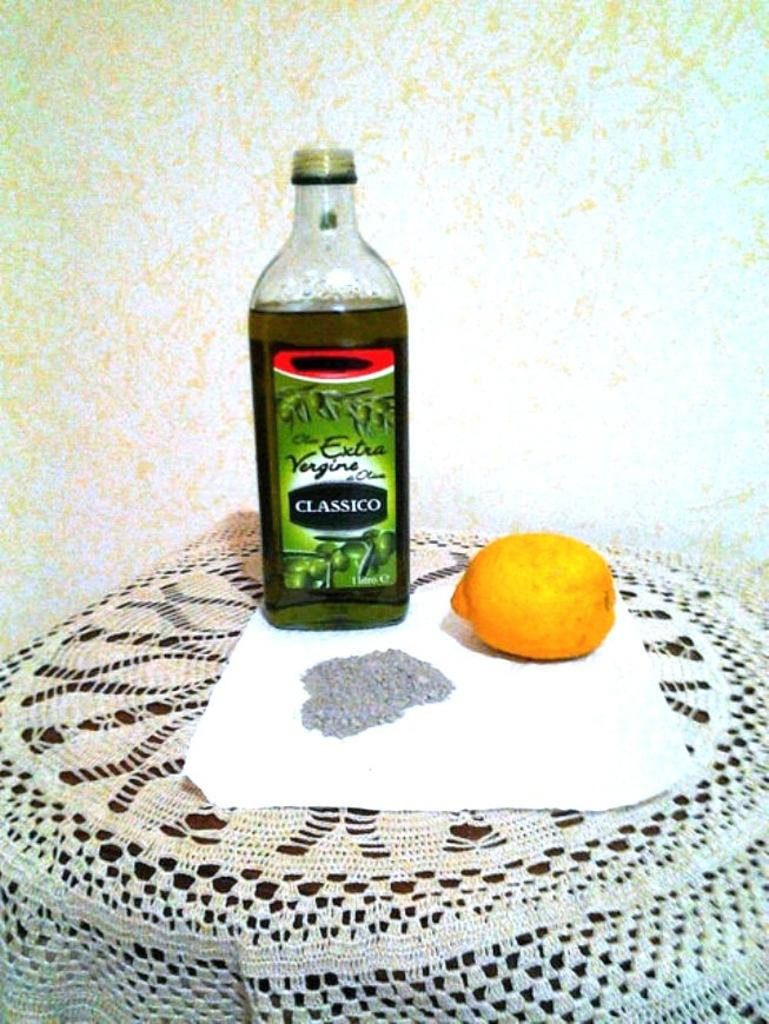What is the main piece of furniture in the image? There is a table in the image. What type of food items can be seen on the table? There are fruits on the table. What else is present on the table besides the fruits? There is a bottle on the table. What type of tax is being discussed in the image? There is no discussion of tax in the image; it features a table with fruits and a bottle. What type of toothbrush is visible in the image? There is no toothbrush present in the image. 